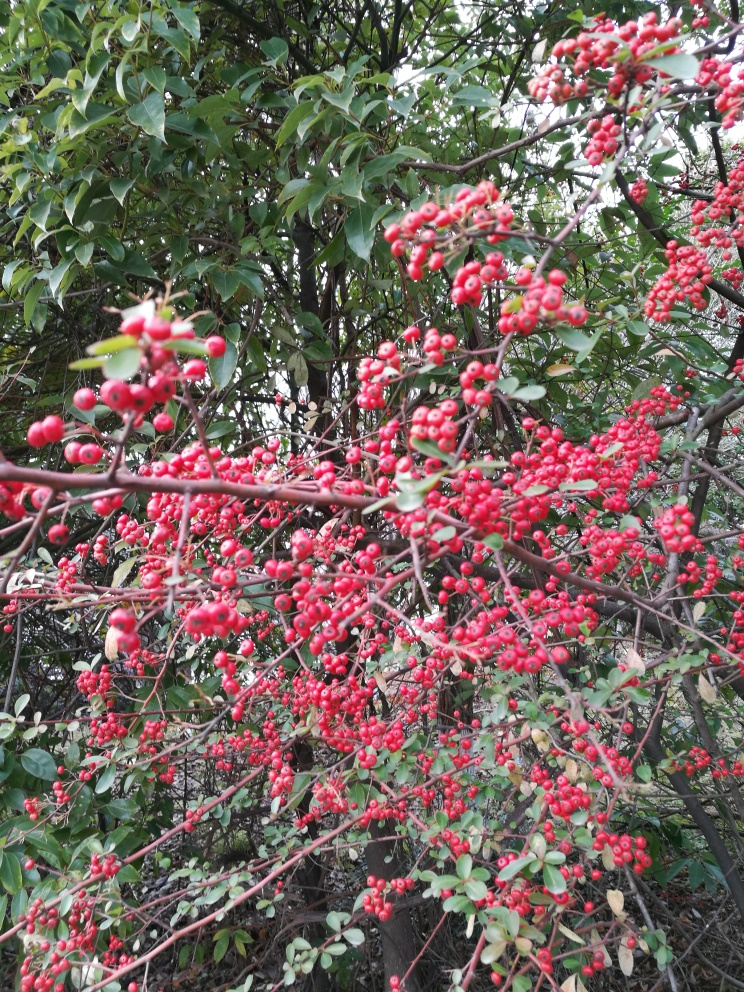Can these berries be used for anything? While visually appealing, the berries of plants like these are often not edible for humans and can sometimes be toxic. However, they are a valuable food source for birds during the winter months. 